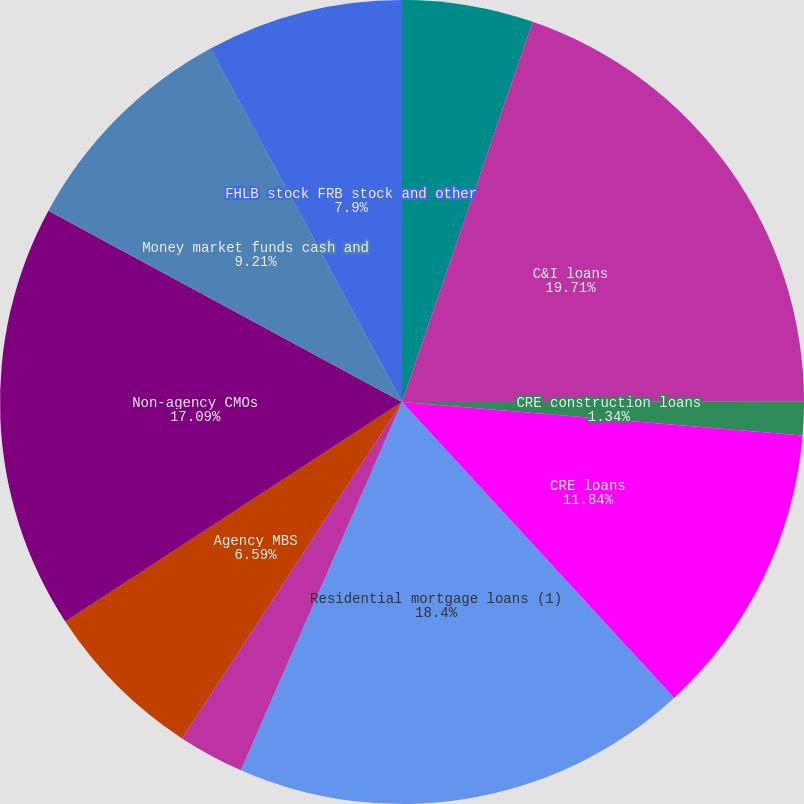<chart> <loc_0><loc_0><loc_500><loc_500><pie_chart><fcel>Loans held for sale<fcel>C&I loans<fcel>CRE construction loans<fcel>CRE loans<fcel>Residential mortgage loans (1)<fcel>Consumer loans<fcel>Agency MBS<fcel>Non-agency CMOs<fcel>Money market funds cash and<fcel>FHLB stock FRB stock and other<nl><fcel>5.27%<fcel>19.72%<fcel>1.34%<fcel>11.84%<fcel>18.4%<fcel>2.65%<fcel>6.59%<fcel>17.09%<fcel>9.21%<fcel>7.9%<nl></chart> 